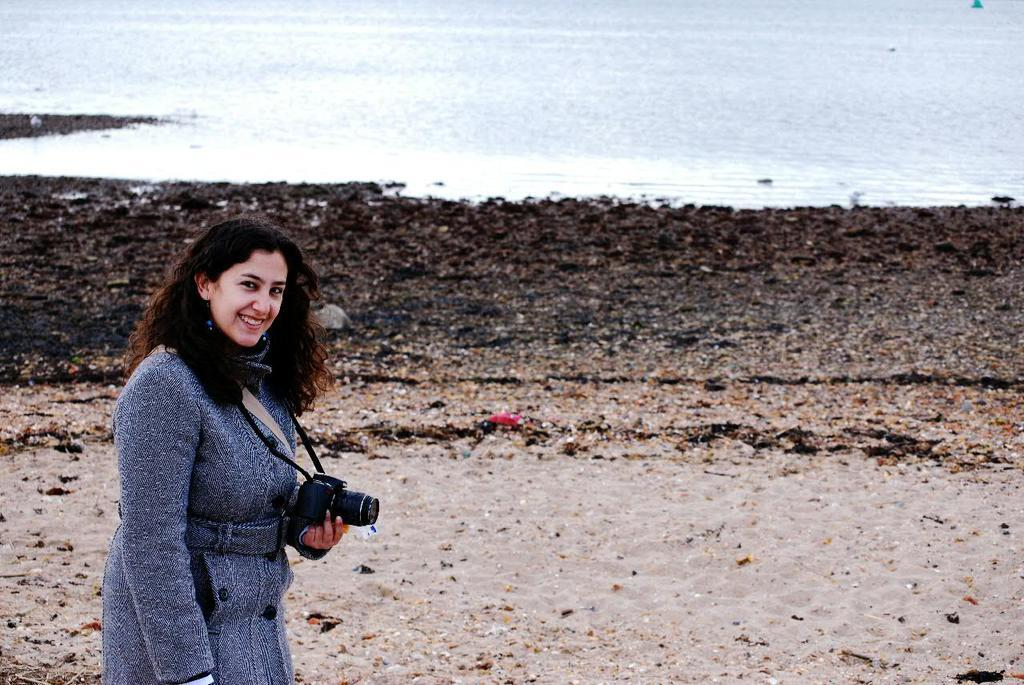What can be seen in the background of the image? There is a river in the background of the image. Can you describe the woman in the image? The woman is wearing an ash-colored jacket and holding a pretty smile on her face. What is the woman holding in her hand? The woman is holding a camera in her hand. How many tin babies are sitting on the riverbank in the image? There are no tin babies present in the image; it features a woman holding a camera and a river in the background. What type of cherry is the woman holding in her hand? The woman is not holding a cherry in her hand; she is holding a camera. 